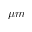Convert formula to latex. <formula><loc_0><loc_0><loc_500><loc_500>\mu m</formula> 